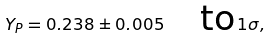Convert formula to latex. <formula><loc_0><loc_0><loc_500><loc_500>Y _ { P } = 0 . 2 3 8 \pm 0 . 0 0 5 \quad \text {to} \, 1 \sigma ,</formula> 